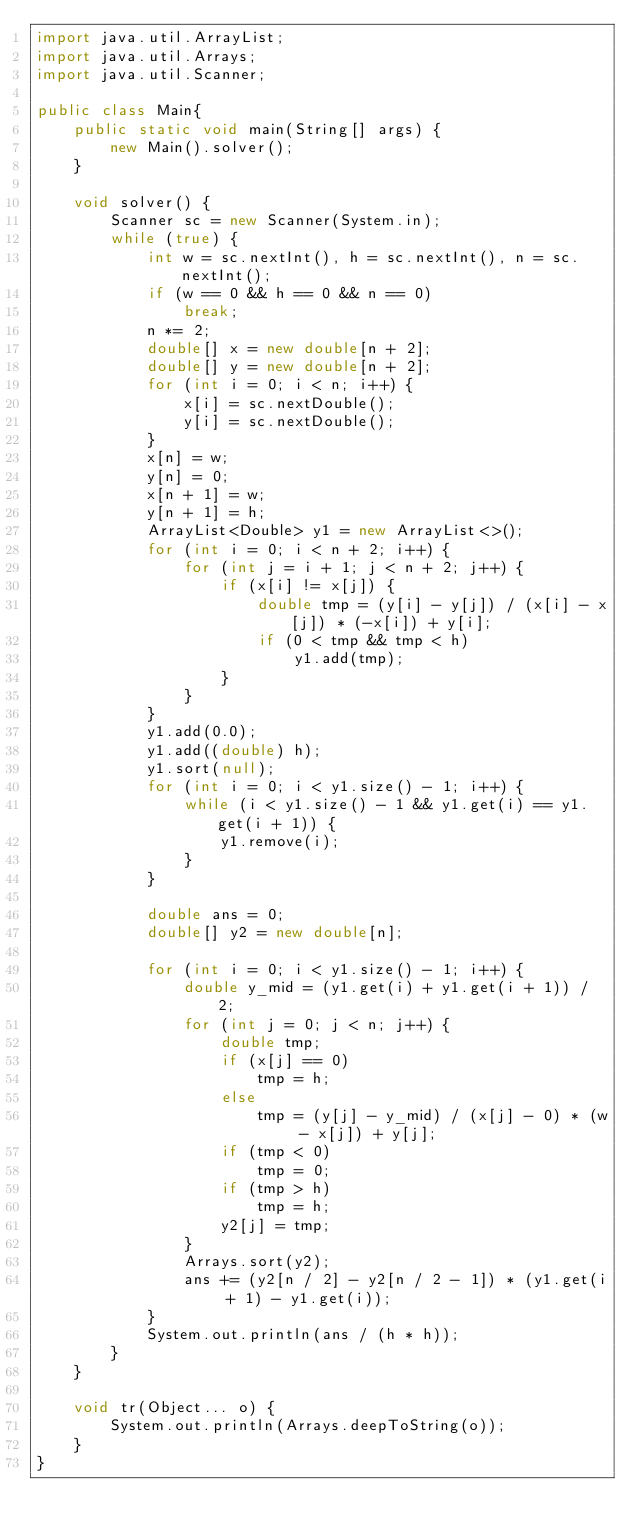<code> <loc_0><loc_0><loc_500><loc_500><_Java_>import java.util.ArrayList;
import java.util.Arrays;
import java.util.Scanner;

public class Main{
	public static void main(String[] args) {
		new Main().solver();
	}

	void solver() {
		Scanner sc = new Scanner(System.in);
		while (true) {
			int w = sc.nextInt(), h = sc.nextInt(), n = sc.nextInt();
			if (w == 0 && h == 0 && n == 0)
				break;
			n *= 2;
			double[] x = new double[n + 2];
			double[] y = new double[n + 2];
			for (int i = 0; i < n; i++) {
				x[i] = sc.nextDouble();
				y[i] = sc.nextDouble();
			}
			x[n] = w;
			y[n] = 0;
			x[n + 1] = w;
			y[n + 1] = h;
			ArrayList<Double> y1 = new ArrayList<>();
			for (int i = 0; i < n + 2; i++) {
				for (int j = i + 1; j < n + 2; j++) {
					if (x[i] != x[j]) {
						double tmp = (y[i] - y[j]) / (x[i] - x[j]) * (-x[i]) + y[i];
						if (0 < tmp && tmp < h)
							y1.add(tmp);
					}
				}
			}
			y1.add(0.0);
			y1.add((double) h);
			y1.sort(null);
			for (int i = 0; i < y1.size() - 1; i++) {
				while (i < y1.size() - 1 && y1.get(i) == y1.get(i + 1)) {
					y1.remove(i);
				}
			}

			double ans = 0;
			double[] y2 = new double[n];

			for (int i = 0; i < y1.size() - 1; i++) {
				double y_mid = (y1.get(i) + y1.get(i + 1)) / 2;
				for (int j = 0; j < n; j++) {
					double tmp;
					if (x[j] == 0)
						tmp = h;
					else
						tmp = (y[j] - y_mid) / (x[j] - 0) * (w - x[j]) + y[j];
					if (tmp < 0)
						tmp = 0;
					if (tmp > h)
						tmp = h;
					y2[j] = tmp;
				}
				Arrays.sort(y2);
				ans += (y2[n / 2] - y2[n / 2 - 1]) * (y1.get(i + 1) - y1.get(i));
			}
			System.out.println(ans / (h * h));
		}
	}

	void tr(Object... o) {
		System.out.println(Arrays.deepToString(o));
	}
}</code> 